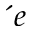Convert formula to latex. <formula><loc_0><loc_0><loc_500><loc_500>{ e }</formula> 